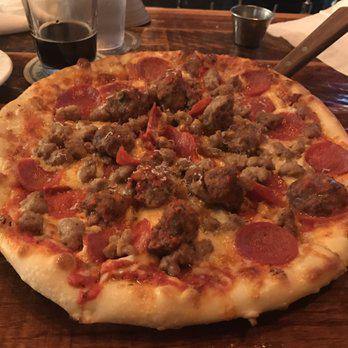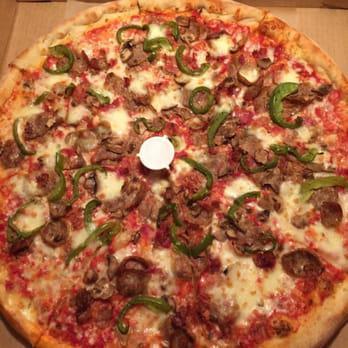The first image is the image on the left, the second image is the image on the right. Considering the images on both sides, is "One image shows a round pizza in a round pan with no slices removed, and the other image shows a pizza slice that is not joined to the rest of the pizza." valid? Answer yes or no. No. The first image is the image on the left, the second image is the image on the right. For the images shown, is this caption "In at least one image there is a pepperoni pizza with a serving utenical underneath at least one slice." true? Answer yes or no. Yes. 